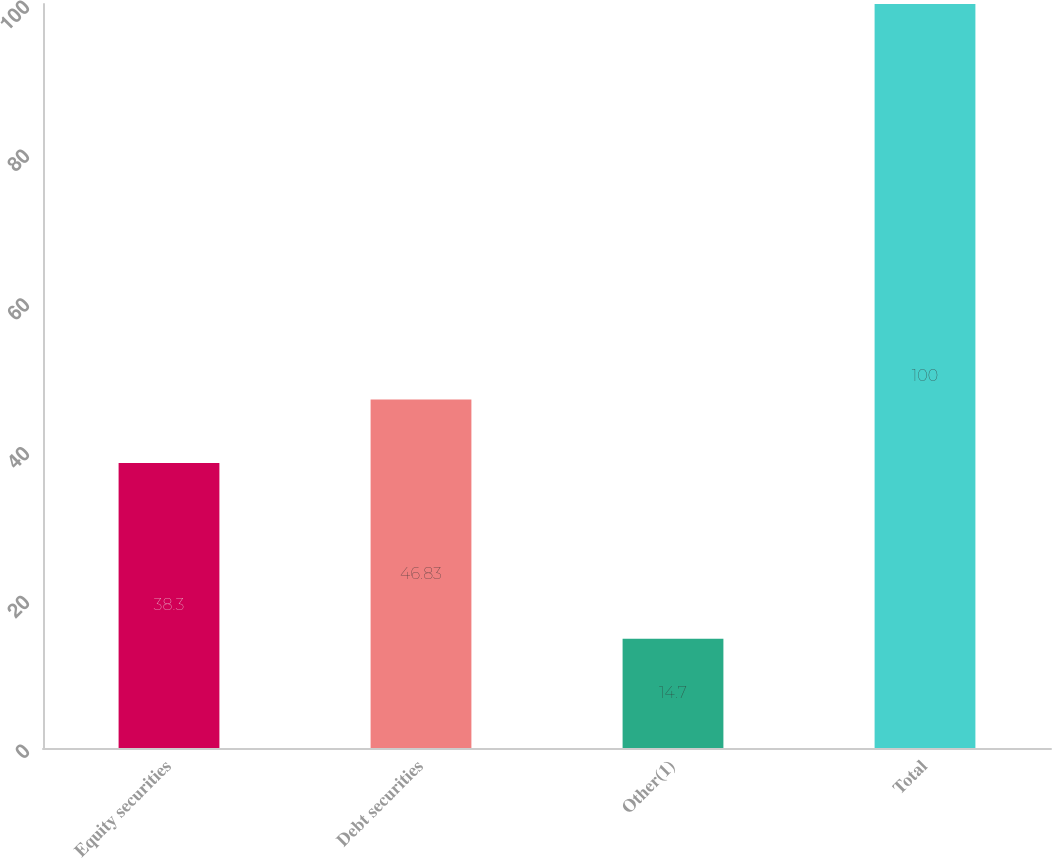Convert chart. <chart><loc_0><loc_0><loc_500><loc_500><bar_chart><fcel>Equity securities<fcel>Debt securities<fcel>Other(1)<fcel>Total<nl><fcel>38.3<fcel>46.83<fcel>14.7<fcel>100<nl></chart> 